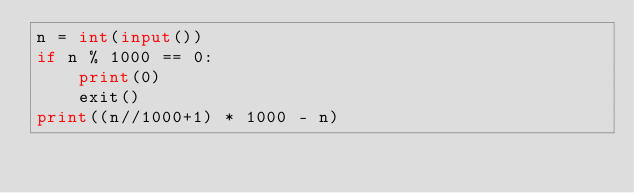<code> <loc_0><loc_0><loc_500><loc_500><_Python_>n = int(input())
if n % 1000 == 0:
    print(0)
    exit()
print((n//1000+1) * 1000 - n)
</code> 